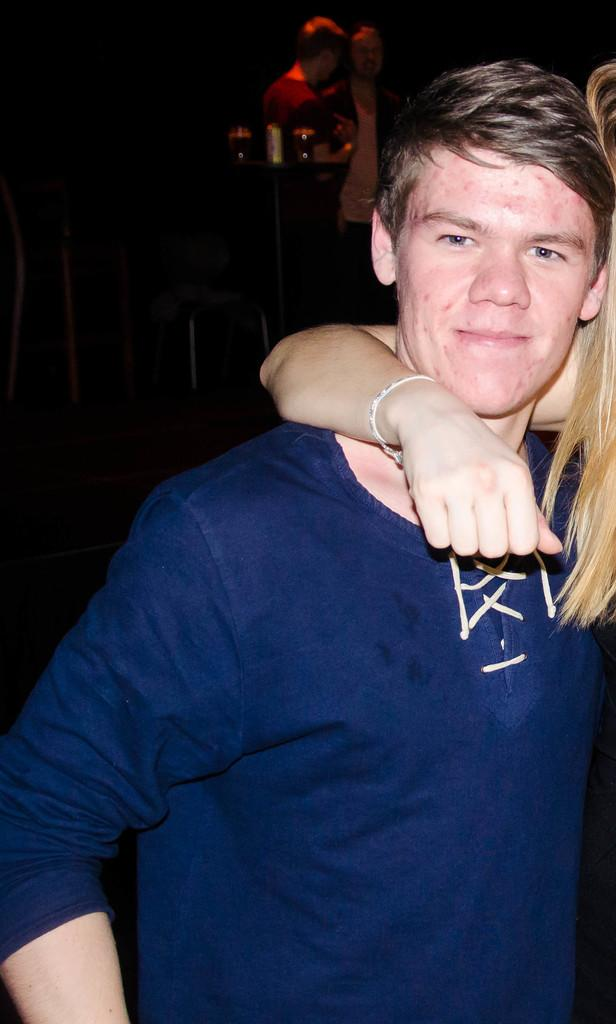What is happening in the image? There are persons standing in the image. Where are the persons standing? The persons are standing on the floor. What objects can be seen on the side table in the image? There are glass tumblers on a side table in the image. What can be seen in the background of the image? There are chairs in the background of the image. What type of feather is being used as a decoration on the chairs in the image? There is no feather present as a decoration on the chairs in the image. Can you tell me how many cherries are on top of the glass tumblers in the image? There are no cherries present on top of the glass tumblers in the image. 